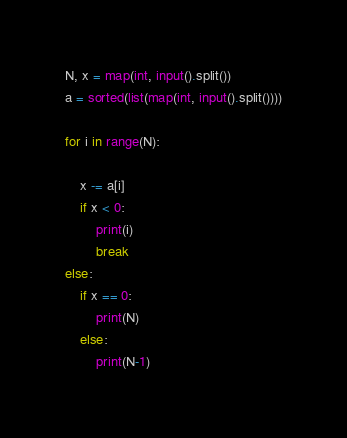Convert code to text. <code><loc_0><loc_0><loc_500><loc_500><_Python_>N, x = map(int, input().split())
a = sorted(list(map(int, input().split())))

for i in range(N):

    x -= a[i]
    if x < 0:
        print(i)
        break    
else:
    if x == 0:
        print(N)
    else:
        print(N-1)    
</code> 